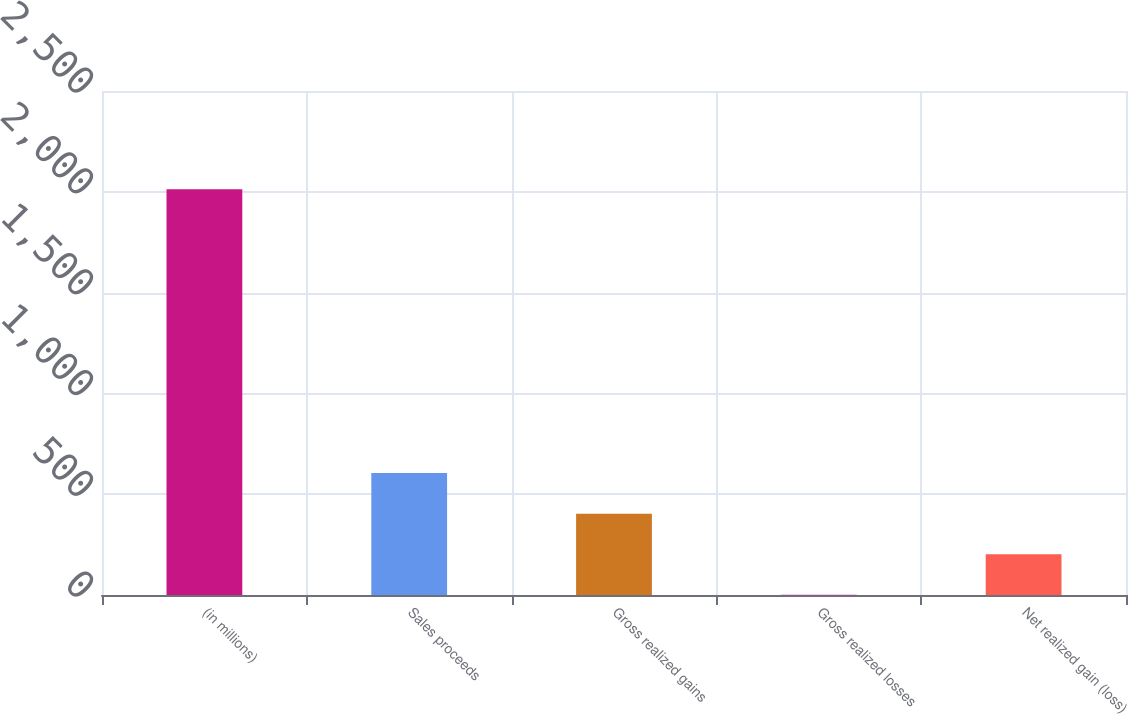Convert chart to OTSL. <chart><loc_0><loc_0><loc_500><loc_500><bar_chart><fcel>(in millions)<fcel>Sales proceeds<fcel>Gross realized gains<fcel>Gross realized losses<fcel>Net realized gain (loss)<nl><fcel>2013<fcel>604.6<fcel>403.4<fcel>1<fcel>202.2<nl></chart> 